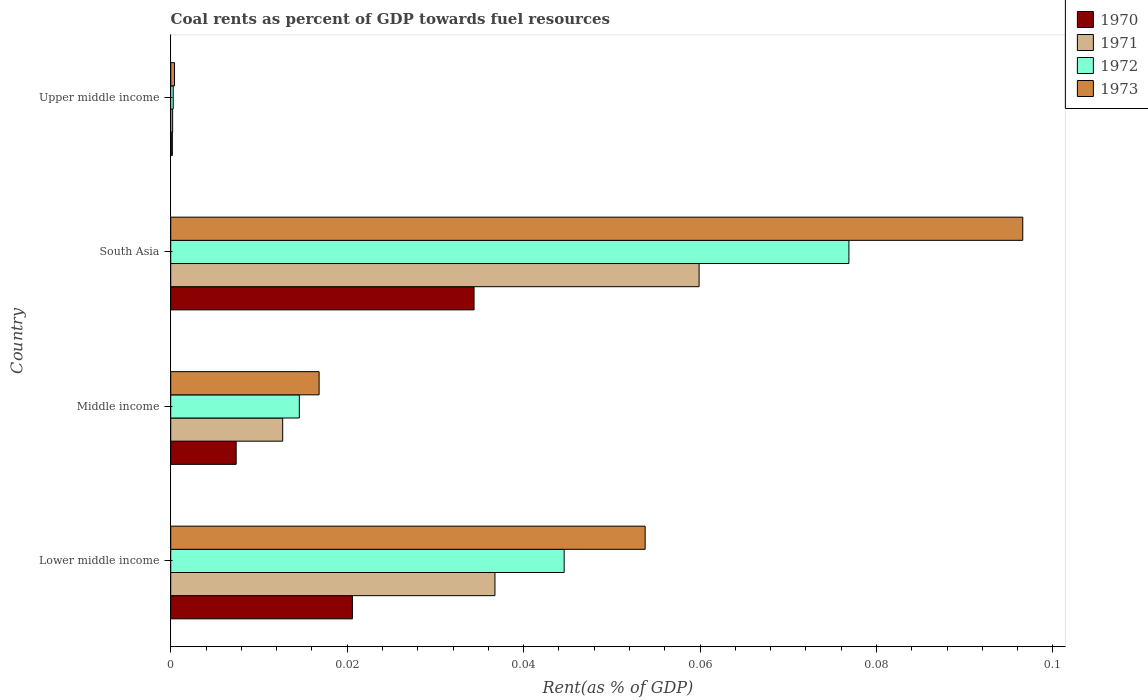Are the number of bars on each tick of the Y-axis equal?
Make the answer very short. Yes. How many bars are there on the 1st tick from the bottom?
Provide a succinct answer. 4. In how many cases, is the number of bars for a given country not equal to the number of legend labels?
Offer a very short reply. 0. What is the coal rent in 1973 in South Asia?
Your answer should be compact. 0.1. Across all countries, what is the maximum coal rent in 1970?
Make the answer very short. 0.03. Across all countries, what is the minimum coal rent in 1971?
Provide a succinct answer. 0. In which country was the coal rent in 1971 minimum?
Keep it short and to the point. Upper middle income. What is the total coal rent in 1973 in the graph?
Give a very brief answer. 0.17. What is the difference between the coal rent in 1972 in Lower middle income and that in Middle income?
Keep it short and to the point. 0.03. What is the difference between the coal rent in 1973 in South Asia and the coal rent in 1970 in Middle income?
Ensure brevity in your answer.  0.09. What is the average coal rent in 1970 per country?
Your answer should be very brief. 0.02. What is the difference between the coal rent in 1971 and coal rent in 1972 in South Asia?
Offer a terse response. -0.02. What is the ratio of the coal rent in 1971 in Middle income to that in Upper middle income?
Make the answer very short. 58.01. What is the difference between the highest and the second highest coal rent in 1972?
Provide a short and direct response. 0.03. What is the difference between the highest and the lowest coal rent in 1972?
Your answer should be compact. 0.08. In how many countries, is the coal rent in 1971 greater than the average coal rent in 1971 taken over all countries?
Give a very brief answer. 2. Is the sum of the coal rent in 1971 in Lower middle income and South Asia greater than the maximum coal rent in 1972 across all countries?
Make the answer very short. Yes. Is it the case that in every country, the sum of the coal rent in 1971 and coal rent in 1973 is greater than the sum of coal rent in 1970 and coal rent in 1972?
Your answer should be very brief. No. What does the 2nd bar from the bottom in South Asia represents?
Provide a short and direct response. 1971. Is it the case that in every country, the sum of the coal rent in 1970 and coal rent in 1973 is greater than the coal rent in 1972?
Make the answer very short. Yes. What is the difference between two consecutive major ticks on the X-axis?
Provide a short and direct response. 0.02. How many legend labels are there?
Provide a short and direct response. 4. What is the title of the graph?
Provide a succinct answer. Coal rents as percent of GDP towards fuel resources. Does "1985" appear as one of the legend labels in the graph?
Your response must be concise. No. What is the label or title of the X-axis?
Keep it short and to the point. Rent(as % of GDP). What is the label or title of the Y-axis?
Your response must be concise. Country. What is the Rent(as % of GDP) of 1970 in Lower middle income?
Your answer should be very brief. 0.02. What is the Rent(as % of GDP) of 1971 in Lower middle income?
Give a very brief answer. 0.04. What is the Rent(as % of GDP) in 1972 in Lower middle income?
Give a very brief answer. 0.04. What is the Rent(as % of GDP) of 1973 in Lower middle income?
Offer a very short reply. 0.05. What is the Rent(as % of GDP) of 1970 in Middle income?
Your response must be concise. 0.01. What is the Rent(as % of GDP) in 1971 in Middle income?
Provide a short and direct response. 0.01. What is the Rent(as % of GDP) of 1972 in Middle income?
Provide a short and direct response. 0.01. What is the Rent(as % of GDP) in 1973 in Middle income?
Offer a terse response. 0.02. What is the Rent(as % of GDP) of 1970 in South Asia?
Make the answer very short. 0.03. What is the Rent(as % of GDP) in 1971 in South Asia?
Your answer should be compact. 0.06. What is the Rent(as % of GDP) in 1972 in South Asia?
Make the answer very short. 0.08. What is the Rent(as % of GDP) in 1973 in South Asia?
Provide a succinct answer. 0.1. What is the Rent(as % of GDP) of 1970 in Upper middle income?
Offer a very short reply. 0. What is the Rent(as % of GDP) of 1971 in Upper middle income?
Your answer should be very brief. 0. What is the Rent(as % of GDP) in 1972 in Upper middle income?
Offer a very short reply. 0. What is the Rent(as % of GDP) of 1973 in Upper middle income?
Keep it short and to the point. 0. Across all countries, what is the maximum Rent(as % of GDP) in 1970?
Your answer should be compact. 0.03. Across all countries, what is the maximum Rent(as % of GDP) of 1971?
Make the answer very short. 0.06. Across all countries, what is the maximum Rent(as % of GDP) of 1972?
Give a very brief answer. 0.08. Across all countries, what is the maximum Rent(as % of GDP) of 1973?
Your answer should be compact. 0.1. Across all countries, what is the minimum Rent(as % of GDP) in 1970?
Your response must be concise. 0. Across all countries, what is the minimum Rent(as % of GDP) in 1971?
Keep it short and to the point. 0. Across all countries, what is the minimum Rent(as % of GDP) in 1972?
Your response must be concise. 0. Across all countries, what is the minimum Rent(as % of GDP) of 1973?
Provide a short and direct response. 0. What is the total Rent(as % of GDP) in 1970 in the graph?
Keep it short and to the point. 0.06. What is the total Rent(as % of GDP) in 1971 in the graph?
Provide a short and direct response. 0.11. What is the total Rent(as % of GDP) in 1972 in the graph?
Provide a short and direct response. 0.14. What is the total Rent(as % of GDP) of 1973 in the graph?
Make the answer very short. 0.17. What is the difference between the Rent(as % of GDP) in 1970 in Lower middle income and that in Middle income?
Your answer should be compact. 0.01. What is the difference between the Rent(as % of GDP) of 1971 in Lower middle income and that in Middle income?
Your answer should be compact. 0.02. What is the difference between the Rent(as % of GDP) in 1972 in Lower middle income and that in Middle income?
Provide a succinct answer. 0.03. What is the difference between the Rent(as % of GDP) of 1973 in Lower middle income and that in Middle income?
Offer a terse response. 0.04. What is the difference between the Rent(as % of GDP) of 1970 in Lower middle income and that in South Asia?
Provide a short and direct response. -0.01. What is the difference between the Rent(as % of GDP) in 1971 in Lower middle income and that in South Asia?
Your answer should be compact. -0.02. What is the difference between the Rent(as % of GDP) in 1972 in Lower middle income and that in South Asia?
Your response must be concise. -0.03. What is the difference between the Rent(as % of GDP) of 1973 in Lower middle income and that in South Asia?
Provide a succinct answer. -0.04. What is the difference between the Rent(as % of GDP) of 1970 in Lower middle income and that in Upper middle income?
Make the answer very short. 0.02. What is the difference between the Rent(as % of GDP) of 1971 in Lower middle income and that in Upper middle income?
Provide a short and direct response. 0.04. What is the difference between the Rent(as % of GDP) of 1972 in Lower middle income and that in Upper middle income?
Provide a short and direct response. 0.04. What is the difference between the Rent(as % of GDP) of 1973 in Lower middle income and that in Upper middle income?
Your answer should be very brief. 0.05. What is the difference between the Rent(as % of GDP) of 1970 in Middle income and that in South Asia?
Keep it short and to the point. -0.03. What is the difference between the Rent(as % of GDP) in 1971 in Middle income and that in South Asia?
Provide a succinct answer. -0.05. What is the difference between the Rent(as % of GDP) of 1972 in Middle income and that in South Asia?
Provide a short and direct response. -0.06. What is the difference between the Rent(as % of GDP) in 1973 in Middle income and that in South Asia?
Ensure brevity in your answer.  -0.08. What is the difference between the Rent(as % of GDP) of 1970 in Middle income and that in Upper middle income?
Give a very brief answer. 0.01. What is the difference between the Rent(as % of GDP) of 1971 in Middle income and that in Upper middle income?
Offer a very short reply. 0.01. What is the difference between the Rent(as % of GDP) of 1972 in Middle income and that in Upper middle income?
Make the answer very short. 0.01. What is the difference between the Rent(as % of GDP) of 1973 in Middle income and that in Upper middle income?
Provide a short and direct response. 0.02. What is the difference between the Rent(as % of GDP) of 1970 in South Asia and that in Upper middle income?
Your answer should be very brief. 0.03. What is the difference between the Rent(as % of GDP) in 1971 in South Asia and that in Upper middle income?
Keep it short and to the point. 0.06. What is the difference between the Rent(as % of GDP) in 1972 in South Asia and that in Upper middle income?
Your answer should be compact. 0.08. What is the difference between the Rent(as % of GDP) of 1973 in South Asia and that in Upper middle income?
Keep it short and to the point. 0.1. What is the difference between the Rent(as % of GDP) in 1970 in Lower middle income and the Rent(as % of GDP) in 1971 in Middle income?
Offer a very short reply. 0.01. What is the difference between the Rent(as % of GDP) in 1970 in Lower middle income and the Rent(as % of GDP) in 1972 in Middle income?
Give a very brief answer. 0.01. What is the difference between the Rent(as % of GDP) of 1970 in Lower middle income and the Rent(as % of GDP) of 1973 in Middle income?
Keep it short and to the point. 0. What is the difference between the Rent(as % of GDP) in 1971 in Lower middle income and the Rent(as % of GDP) in 1972 in Middle income?
Your answer should be compact. 0.02. What is the difference between the Rent(as % of GDP) in 1971 in Lower middle income and the Rent(as % of GDP) in 1973 in Middle income?
Offer a terse response. 0.02. What is the difference between the Rent(as % of GDP) in 1972 in Lower middle income and the Rent(as % of GDP) in 1973 in Middle income?
Your response must be concise. 0.03. What is the difference between the Rent(as % of GDP) in 1970 in Lower middle income and the Rent(as % of GDP) in 1971 in South Asia?
Offer a terse response. -0.04. What is the difference between the Rent(as % of GDP) in 1970 in Lower middle income and the Rent(as % of GDP) in 1972 in South Asia?
Your answer should be very brief. -0.06. What is the difference between the Rent(as % of GDP) in 1970 in Lower middle income and the Rent(as % of GDP) in 1973 in South Asia?
Keep it short and to the point. -0.08. What is the difference between the Rent(as % of GDP) in 1971 in Lower middle income and the Rent(as % of GDP) in 1972 in South Asia?
Provide a succinct answer. -0.04. What is the difference between the Rent(as % of GDP) of 1971 in Lower middle income and the Rent(as % of GDP) of 1973 in South Asia?
Provide a succinct answer. -0.06. What is the difference between the Rent(as % of GDP) in 1972 in Lower middle income and the Rent(as % of GDP) in 1973 in South Asia?
Offer a terse response. -0.05. What is the difference between the Rent(as % of GDP) of 1970 in Lower middle income and the Rent(as % of GDP) of 1971 in Upper middle income?
Offer a terse response. 0.02. What is the difference between the Rent(as % of GDP) in 1970 in Lower middle income and the Rent(as % of GDP) in 1972 in Upper middle income?
Offer a very short reply. 0.02. What is the difference between the Rent(as % of GDP) of 1970 in Lower middle income and the Rent(as % of GDP) of 1973 in Upper middle income?
Make the answer very short. 0.02. What is the difference between the Rent(as % of GDP) in 1971 in Lower middle income and the Rent(as % of GDP) in 1972 in Upper middle income?
Provide a short and direct response. 0.04. What is the difference between the Rent(as % of GDP) in 1971 in Lower middle income and the Rent(as % of GDP) in 1973 in Upper middle income?
Give a very brief answer. 0.04. What is the difference between the Rent(as % of GDP) in 1972 in Lower middle income and the Rent(as % of GDP) in 1973 in Upper middle income?
Give a very brief answer. 0.04. What is the difference between the Rent(as % of GDP) of 1970 in Middle income and the Rent(as % of GDP) of 1971 in South Asia?
Your answer should be very brief. -0.05. What is the difference between the Rent(as % of GDP) in 1970 in Middle income and the Rent(as % of GDP) in 1972 in South Asia?
Give a very brief answer. -0.07. What is the difference between the Rent(as % of GDP) of 1970 in Middle income and the Rent(as % of GDP) of 1973 in South Asia?
Your answer should be compact. -0.09. What is the difference between the Rent(as % of GDP) of 1971 in Middle income and the Rent(as % of GDP) of 1972 in South Asia?
Your response must be concise. -0.06. What is the difference between the Rent(as % of GDP) in 1971 in Middle income and the Rent(as % of GDP) in 1973 in South Asia?
Your answer should be very brief. -0.08. What is the difference between the Rent(as % of GDP) of 1972 in Middle income and the Rent(as % of GDP) of 1973 in South Asia?
Offer a terse response. -0.08. What is the difference between the Rent(as % of GDP) of 1970 in Middle income and the Rent(as % of GDP) of 1971 in Upper middle income?
Make the answer very short. 0.01. What is the difference between the Rent(as % of GDP) in 1970 in Middle income and the Rent(as % of GDP) in 1972 in Upper middle income?
Provide a succinct answer. 0.01. What is the difference between the Rent(as % of GDP) in 1970 in Middle income and the Rent(as % of GDP) in 1973 in Upper middle income?
Offer a terse response. 0.01. What is the difference between the Rent(as % of GDP) of 1971 in Middle income and the Rent(as % of GDP) of 1972 in Upper middle income?
Offer a terse response. 0.01. What is the difference between the Rent(as % of GDP) in 1971 in Middle income and the Rent(as % of GDP) in 1973 in Upper middle income?
Provide a succinct answer. 0.01. What is the difference between the Rent(as % of GDP) in 1972 in Middle income and the Rent(as % of GDP) in 1973 in Upper middle income?
Keep it short and to the point. 0.01. What is the difference between the Rent(as % of GDP) in 1970 in South Asia and the Rent(as % of GDP) in 1971 in Upper middle income?
Provide a short and direct response. 0.03. What is the difference between the Rent(as % of GDP) of 1970 in South Asia and the Rent(as % of GDP) of 1972 in Upper middle income?
Your answer should be very brief. 0.03. What is the difference between the Rent(as % of GDP) in 1970 in South Asia and the Rent(as % of GDP) in 1973 in Upper middle income?
Your answer should be very brief. 0.03. What is the difference between the Rent(as % of GDP) in 1971 in South Asia and the Rent(as % of GDP) in 1972 in Upper middle income?
Offer a terse response. 0.06. What is the difference between the Rent(as % of GDP) of 1971 in South Asia and the Rent(as % of GDP) of 1973 in Upper middle income?
Offer a terse response. 0.06. What is the difference between the Rent(as % of GDP) in 1972 in South Asia and the Rent(as % of GDP) in 1973 in Upper middle income?
Give a very brief answer. 0.08. What is the average Rent(as % of GDP) in 1970 per country?
Provide a succinct answer. 0.02. What is the average Rent(as % of GDP) in 1971 per country?
Your answer should be compact. 0.03. What is the average Rent(as % of GDP) of 1972 per country?
Offer a very short reply. 0.03. What is the average Rent(as % of GDP) in 1973 per country?
Offer a very short reply. 0.04. What is the difference between the Rent(as % of GDP) of 1970 and Rent(as % of GDP) of 1971 in Lower middle income?
Give a very brief answer. -0.02. What is the difference between the Rent(as % of GDP) in 1970 and Rent(as % of GDP) in 1972 in Lower middle income?
Provide a succinct answer. -0.02. What is the difference between the Rent(as % of GDP) of 1970 and Rent(as % of GDP) of 1973 in Lower middle income?
Give a very brief answer. -0.03. What is the difference between the Rent(as % of GDP) in 1971 and Rent(as % of GDP) in 1972 in Lower middle income?
Make the answer very short. -0.01. What is the difference between the Rent(as % of GDP) in 1971 and Rent(as % of GDP) in 1973 in Lower middle income?
Provide a succinct answer. -0.02. What is the difference between the Rent(as % of GDP) of 1972 and Rent(as % of GDP) of 1973 in Lower middle income?
Offer a terse response. -0.01. What is the difference between the Rent(as % of GDP) in 1970 and Rent(as % of GDP) in 1971 in Middle income?
Offer a terse response. -0.01. What is the difference between the Rent(as % of GDP) in 1970 and Rent(as % of GDP) in 1972 in Middle income?
Provide a succinct answer. -0.01. What is the difference between the Rent(as % of GDP) in 1970 and Rent(as % of GDP) in 1973 in Middle income?
Your answer should be compact. -0.01. What is the difference between the Rent(as % of GDP) of 1971 and Rent(as % of GDP) of 1972 in Middle income?
Give a very brief answer. -0. What is the difference between the Rent(as % of GDP) of 1971 and Rent(as % of GDP) of 1973 in Middle income?
Ensure brevity in your answer.  -0. What is the difference between the Rent(as % of GDP) of 1972 and Rent(as % of GDP) of 1973 in Middle income?
Make the answer very short. -0. What is the difference between the Rent(as % of GDP) of 1970 and Rent(as % of GDP) of 1971 in South Asia?
Provide a short and direct response. -0.03. What is the difference between the Rent(as % of GDP) of 1970 and Rent(as % of GDP) of 1972 in South Asia?
Give a very brief answer. -0.04. What is the difference between the Rent(as % of GDP) in 1970 and Rent(as % of GDP) in 1973 in South Asia?
Keep it short and to the point. -0.06. What is the difference between the Rent(as % of GDP) of 1971 and Rent(as % of GDP) of 1972 in South Asia?
Make the answer very short. -0.02. What is the difference between the Rent(as % of GDP) in 1971 and Rent(as % of GDP) in 1973 in South Asia?
Offer a terse response. -0.04. What is the difference between the Rent(as % of GDP) in 1972 and Rent(as % of GDP) in 1973 in South Asia?
Your response must be concise. -0.02. What is the difference between the Rent(as % of GDP) in 1970 and Rent(as % of GDP) in 1971 in Upper middle income?
Offer a very short reply. -0. What is the difference between the Rent(as % of GDP) in 1970 and Rent(as % of GDP) in 1972 in Upper middle income?
Offer a very short reply. -0. What is the difference between the Rent(as % of GDP) of 1970 and Rent(as % of GDP) of 1973 in Upper middle income?
Ensure brevity in your answer.  -0. What is the difference between the Rent(as % of GDP) in 1971 and Rent(as % of GDP) in 1972 in Upper middle income?
Make the answer very short. -0. What is the difference between the Rent(as % of GDP) of 1971 and Rent(as % of GDP) of 1973 in Upper middle income?
Your answer should be compact. -0. What is the difference between the Rent(as % of GDP) of 1972 and Rent(as % of GDP) of 1973 in Upper middle income?
Give a very brief answer. -0. What is the ratio of the Rent(as % of GDP) of 1970 in Lower middle income to that in Middle income?
Your answer should be very brief. 2.78. What is the ratio of the Rent(as % of GDP) in 1971 in Lower middle income to that in Middle income?
Provide a short and direct response. 2.9. What is the ratio of the Rent(as % of GDP) in 1972 in Lower middle income to that in Middle income?
Offer a very short reply. 3.06. What is the ratio of the Rent(as % of GDP) in 1973 in Lower middle income to that in Middle income?
Offer a terse response. 3.2. What is the ratio of the Rent(as % of GDP) in 1970 in Lower middle income to that in South Asia?
Your answer should be very brief. 0.6. What is the ratio of the Rent(as % of GDP) of 1971 in Lower middle income to that in South Asia?
Provide a short and direct response. 0.61. What is the ratio of the Rent(as % of GDP) of 1972 in Lower middle income to that in South Asia?
Offer a very short reply. 0.58. What is the ratio of the Rent(as % of GDP) of 1973 in Lower middle income to that in South Asia?
Provide a succinct answer. 0.56. What is the ratio of the Rent(as % of GDP) in 1970 in Lower middle income to that in Upper middle income?
Give a very brief answer. 112.03. What is the ratio of the Rent(as % of GDP) of 1971 in Lower middle income to that in Upper middle income?
Your response must be concise. 167.98. What is the ratio of the Rent(as % of GDP) in 1972 in Lower middle income to that in Upper middle income?
Offer a terse response. 156.82. What is the ratio of the Rent(as % of GDP) of 1973 in Lower middle income to that in Upper middle income?
Ensure brevity in your answer.  124.82. What is the ratio of the Rent(as % of GDP) of 1970 in Middle income to that in South Asia?
Offer a terse response. 0.22. What is the ratio of the Rent(as % of GDP) of 1971 in Middle income to that in South Asia?
Make the answer very short. 0.21. What is the ratio of the Rent(as % of GDP) of 1972 in Middle income to that in South Asia?
Make the answer very short. 0.19. What is the ratio of the Rent(as % of GDP) in 1973 in Middle income to that in South Asia?
Offer a terse response. 0.17. What is the ratio of the Rent(as % of GDP) of 1970 in Middle income to that in Upper middle income?
Offer a terse response. 40.36. What is the ratio of the Rent(as % of GDP) of 1971 in Middle income to that in Upper middle income?
Your answer should be compact. 58.01. What is the ratio of the Rent(as % of GDP) of 1972 in Middle income to that in Upper middle income?
Make the answer very short. 51.25. What is the ratio of the Rent(as % of GDP) of 1973 in Middle income to that in Upper middle income?
Offer a very short reply. 39.04. What is the ratio of the Rent(as % of GDP) in 1970 in South Asia to that in Upper middle income?
Offer a very short reply. 187.05. What is the ratio of the Rent(as % of GDP) in 1971 in South Asia to that in Upper middle income?
Ensure brevity in your answer.  273.74. What is the ratio of the Rent(as % of GDP) of 1972 in South Asia to that in Upper middle income?
Offer a terse response. 270.32. What is the ratio of the Rent(as % of GDP) in 1973 in South Asia to that in Upper middle income?
Your answer should be very brief. 224.18. What is the difference between the highest and the second highest Rent(as % of GDP) of 1970?
Make the answer very short. 0.01. What is the difference between the highest and the second highest Rent(as % of GDP) in 1971?
Your response must be concise. 0.02. What is the difference between the highest and the second highest Rent(as % of GDP) in 1972?
Provide a succinct answer. 0.03. What is the difference between the highest and the second highest Rent(as % of GDP) of 1973?
Provide a succinct answer. 0.04. What is the difference between the highest and the lowest Rent(as % of GDP) of 1970?
Make the answer very short. 0.03. What is the difference between the highest and the lowest Rent(as % of GDP) in 1971?
Provide a short and direct response. 0.06. What is the difference between the highest and the lowest Rent(as % of GDP) of 1972?
Provide a short and direct response. 0.08. What is the difference between the highest and the lowest Rent(as % of GDP) in 1973?
Provide a short and direct response. 0.1. 